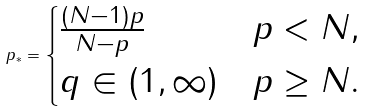<formula> <loc_0><loc_0><loc_500><loc_500>p _ { * } = \begin{cases} \frac { ( N - 1 ) p } { N - p } & p < N , \\ q \in ( 1 , \infty ) & p \geq N . \end{cases}</formula> 